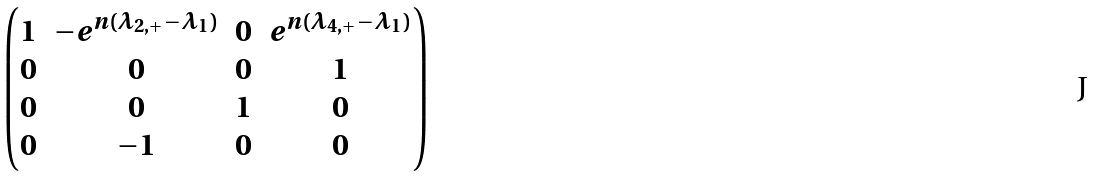Convert formula to latex. <formula><loc_0><loc_0><loc_500><loc_500>\begin{pmatrix} 1 & - e ^ { n ( \lambda _ { 2 , + } - \lambda _ { 1 } ) } & 0 & e ^ { n ( \lambda _ { 4 , + } - \lambda _ { 1 } ) } \\ 0 & 0 & 0 & 1 \\ 0 & 0 & 1 & 0 \\ 0 & - 1 & 0 & 0 \end{pmatrix}</formula> 